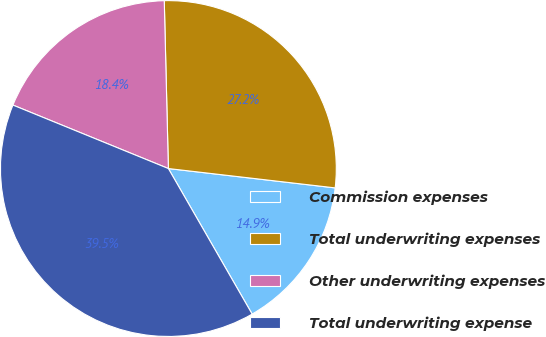<chart> <loc_0><loc_0><loc_500><loc_500><pie_chart><fcel>Commission expenses<fcel>Total underwriting expenses<fcel>Other underwriting expenses<fcel>Total underwriting expense<nl><fcel>14.85%<fcel>27.23%<fcel>18.44%<fcel>39.48%<nl></chart> 